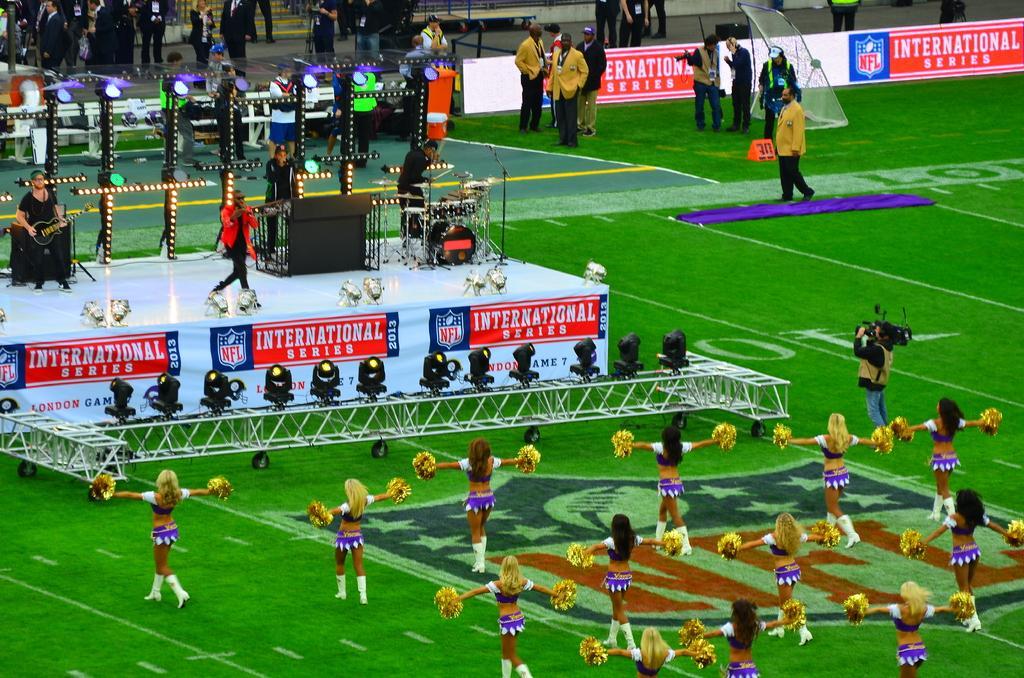How would you summarize this image in a sentence or two? This picture is clicked outside. In the foreground we can see the group of women holding some objects and standing and we can see a person seems to be holding a camera and standing and we can see the green grass, focusing lights, metal rods, text on the banners and we can see the group of persons standing and seems to be playing the musical instruments. In the background we can see the group of persons and many other objects. 